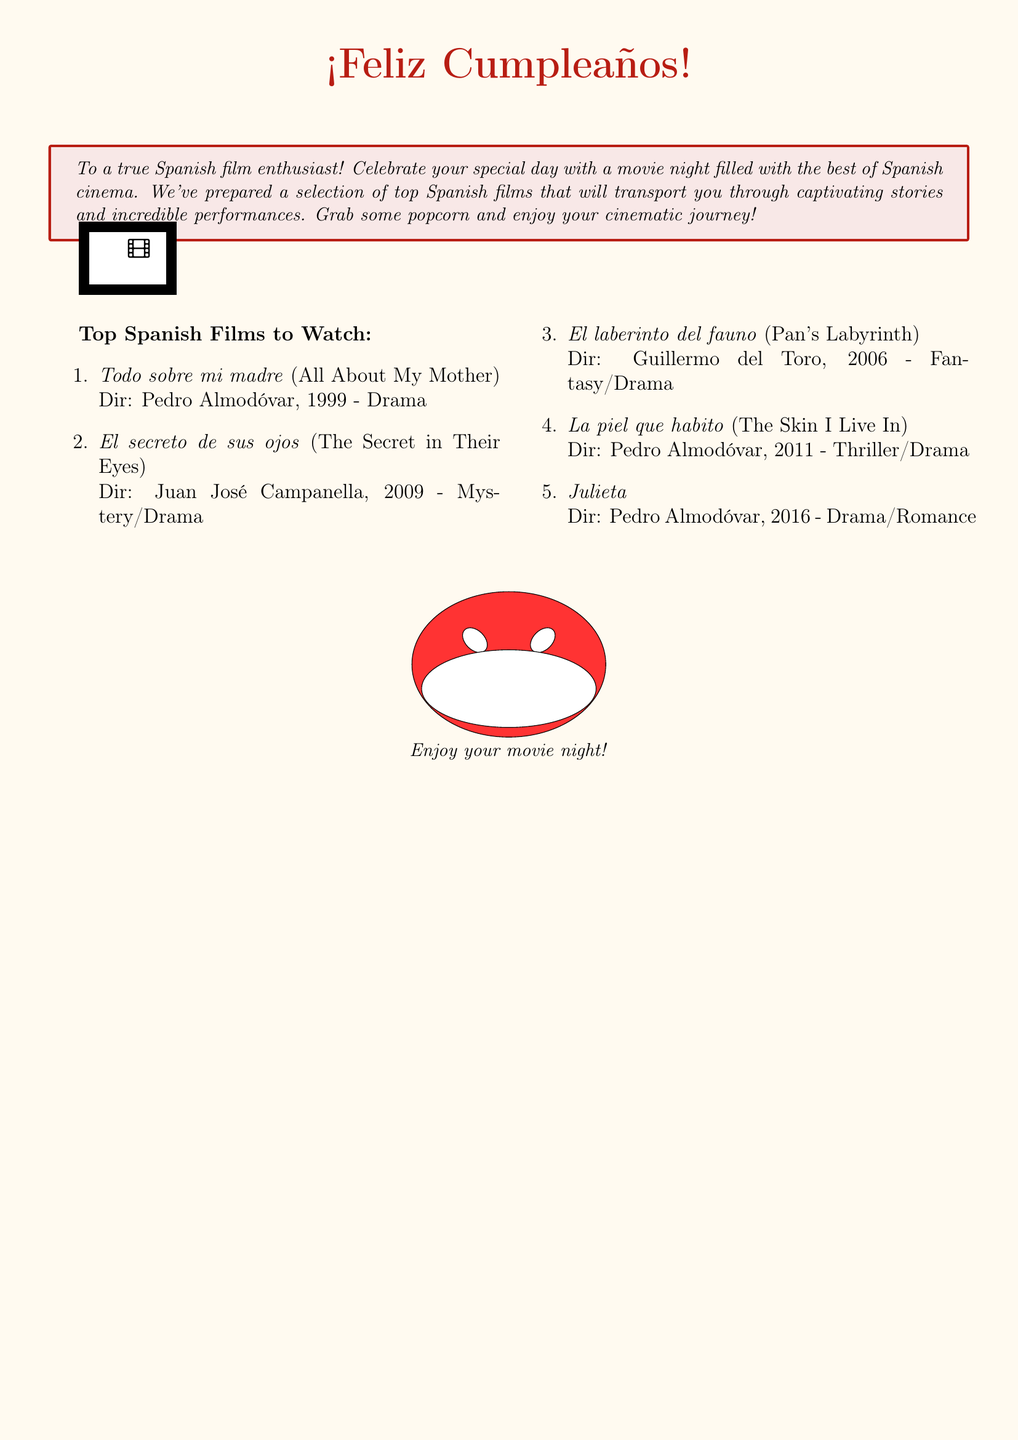What is the theme of the birthday card? The card has a movie night theme, celebrating Spanish cinema.
Answer: Movie night Who is the greeting card addressed to? The card is addressed to a true Spanish film enthusiast.
Answer: True Spanish film enthusiast How many top Spanish films are listed? There are five top Spanish films included in the card.
Answer: Five What year was "Todo sobre mi madre" released? The movie "Todo sobre mi madre" was released in 1999.
Answer: 1999 Who directed "El laberinto del fauno"? "El laberinto del fauno" was directed by Guillermo del Toro.
Answer: Guillermo del Toro Which film genre is "El secreto de sus ojos"? "El secreto de sus ojos" falls under the mystery/drama genre.
Answer: Mystery/Drama What color is used for the greeting at the top? The greeting at the top is in a movie red color.
Answer: Movie red What is recommended to enjoy during the movie night? The greeting suggests grabbing some popcorn.
Answer: Popcorn What is the last movie listed in the selection? The last movie listed is "Julieta".
Answer: Julieta 